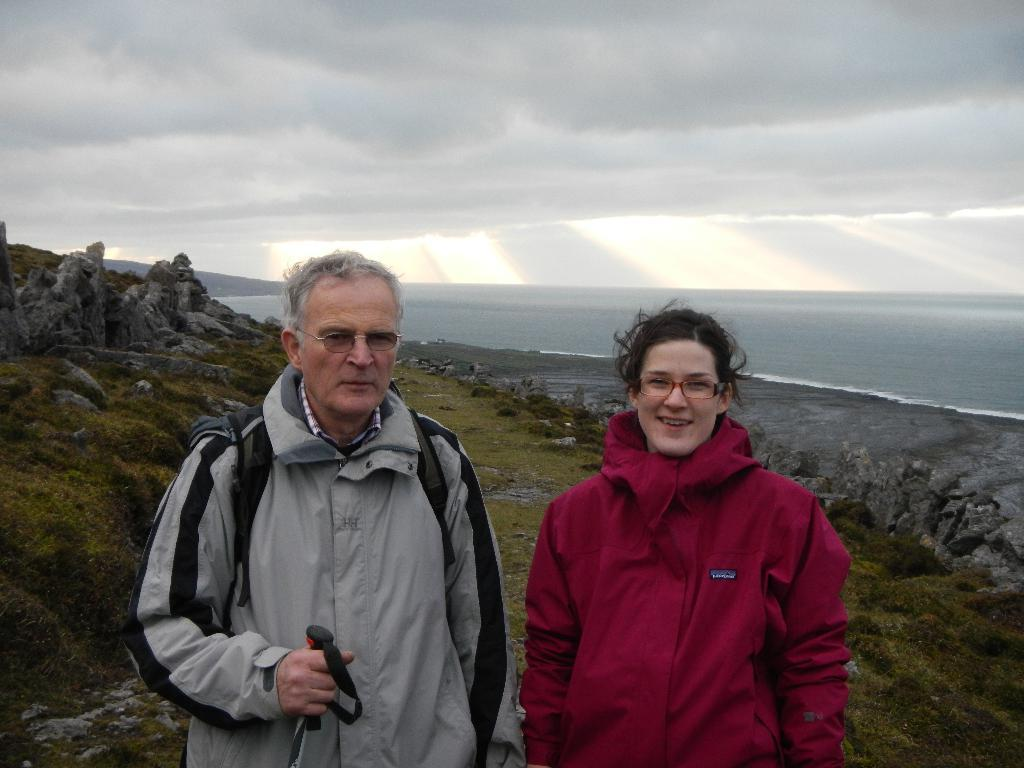How many people are in the image? There are two persons in the image. What are the persons doing in the image? The persons are standing and smiling. What can be seen in the background of the image? There are mountains and the sky visible in the background of the image. What type of paint is being used by the persons in the image? There is no paint or painting activity present in the image. Is there a volcano visible in the background of the image? No, there is no volcano visible in the image; only mountains and the sky are present in the background. 